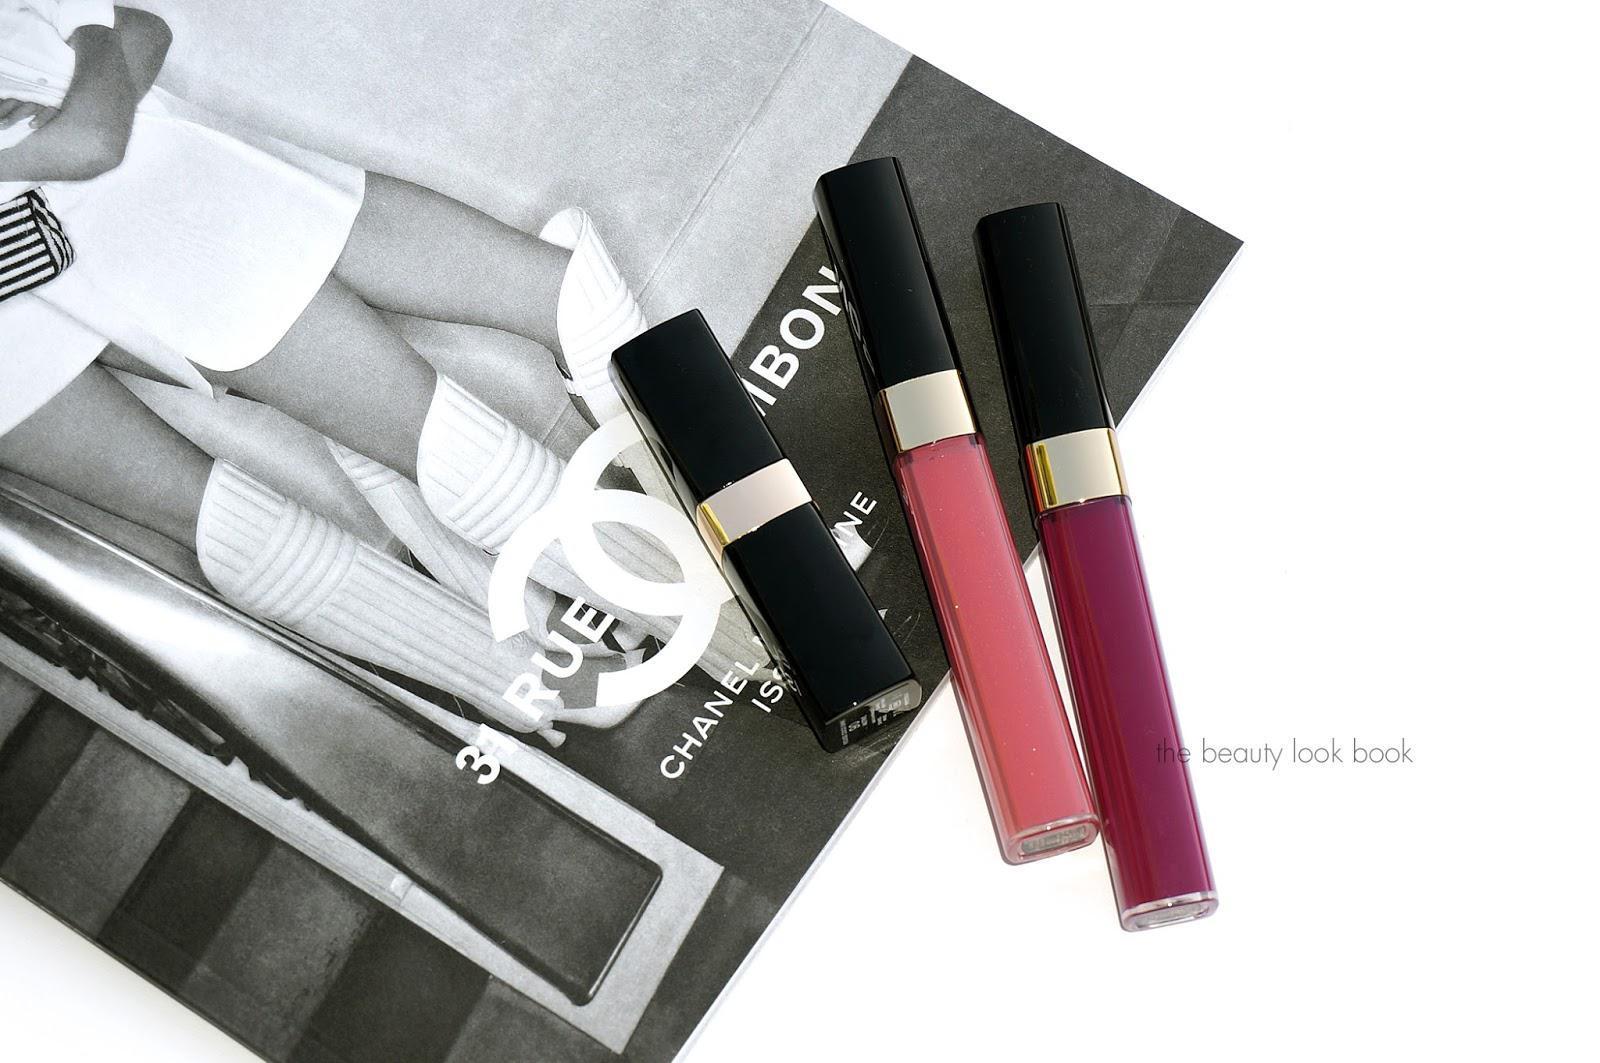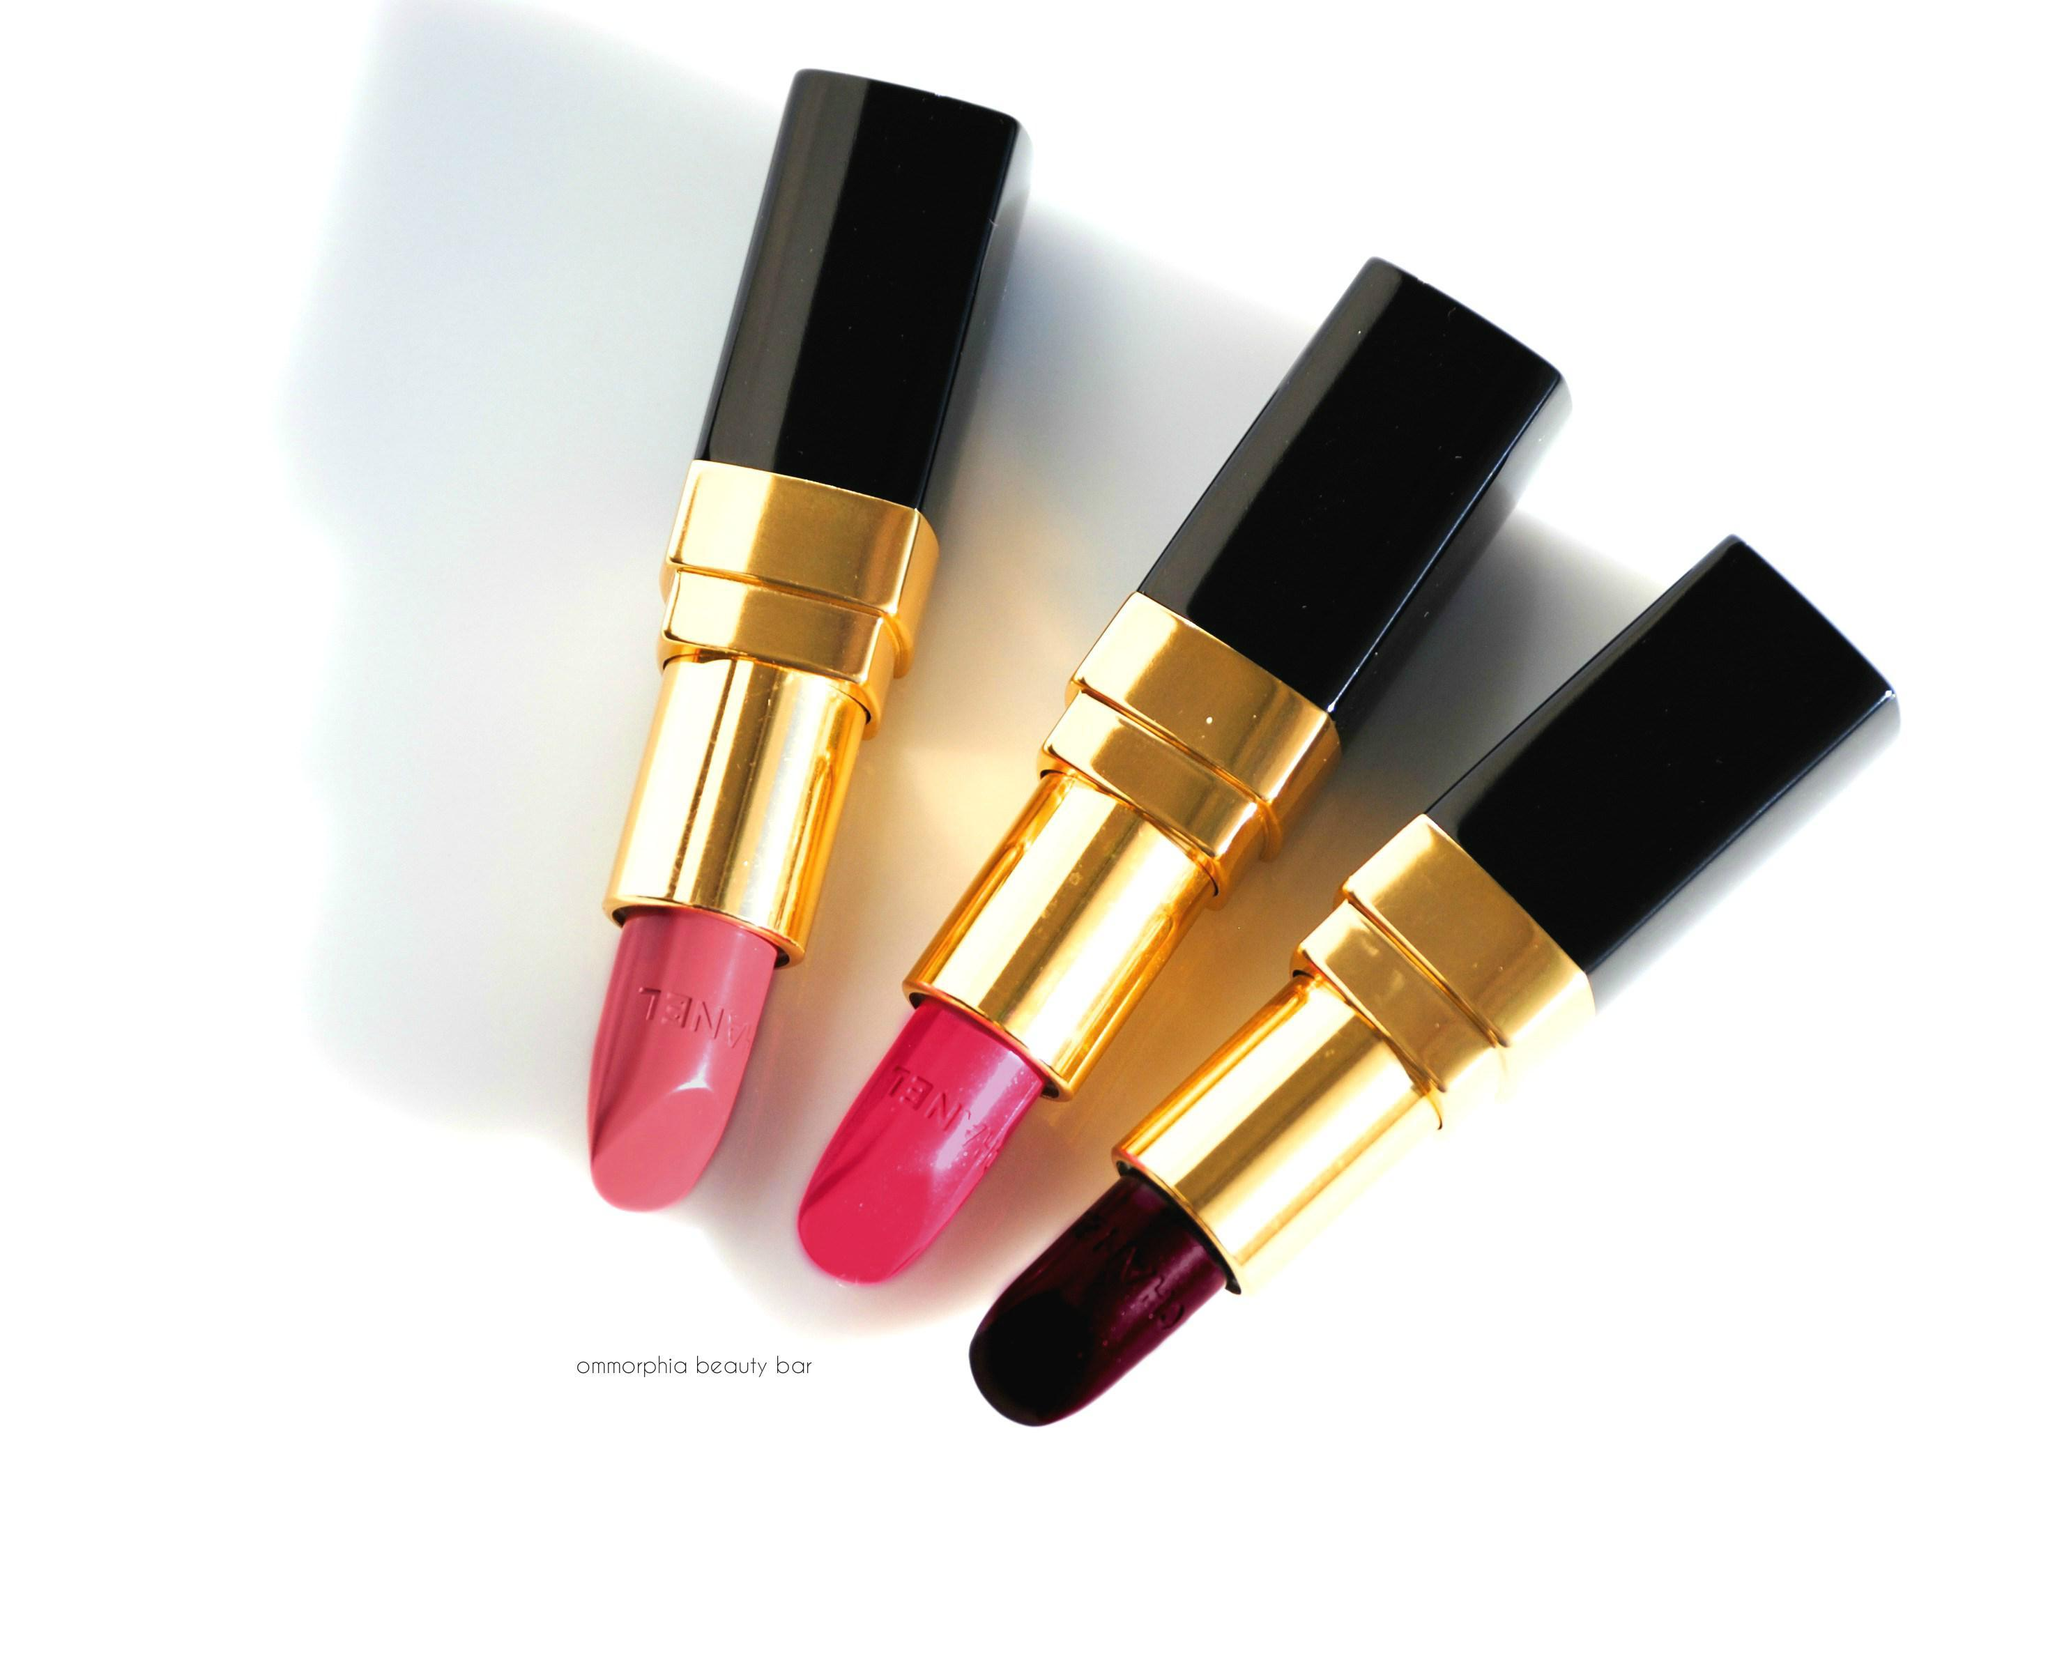The first image is the image on the left, the second image is the image on the right. For the images displayed, is the sentence "The left image includes at least one capped and one uncapped lipstick wand, and the right image includes at least one capped lipstick wand but no uncapped lip makeup." factually correct? Answer yes or no. No. The first image is the image on the left, the second image is the image on the right. Given the left and right images, does the statement "There are at least 8 different shades of lip gloss in their tubes." hold true? Answer yes or no. No. 